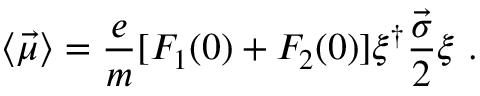Convert formula to latex. <formula><loc_0><loc_0><loc_500><loc_500>\langle \vec { \mu } \rangle = \frac { e } { m } [ F _ { 1 } ( 0 ) + F _ { 2 } ( 0 ) ] { \xi } ^ { \dagger } \frac { \vec { \sigma } } { 2 } \xi \ .</formula> 